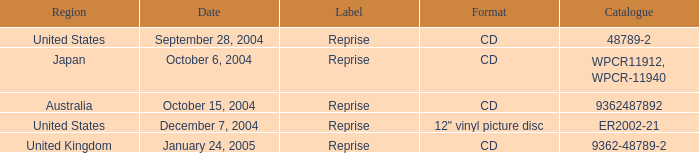Name the date that is a cd September 28, 2004, October 6, 2004, October 15, 2004, January 24, 2005. Would you be able to parse every entry in this table? {'header': ['Region', 'Date', 'Label', 'Format', 'Catalogue'], 'rows': [['United States', 'September 28, 2004', 'Reprise', 'CD', '48789-2'], ['Japan', 'October 6, 2004', 'Reprise', 'CD', 'WPCR11912, WPCR-11940'], ['Australia', 'October 15, 2004', 'Reprise', 'CD', '9362487892'], ['United States', 'December 7, 2004', 'Reprise', '12" vinyl picture disc', 'ER2002-21'], ['United Kingdom', 'January 24, 2005', 'Reprise', 'CD', '9362-48789-2']]} 